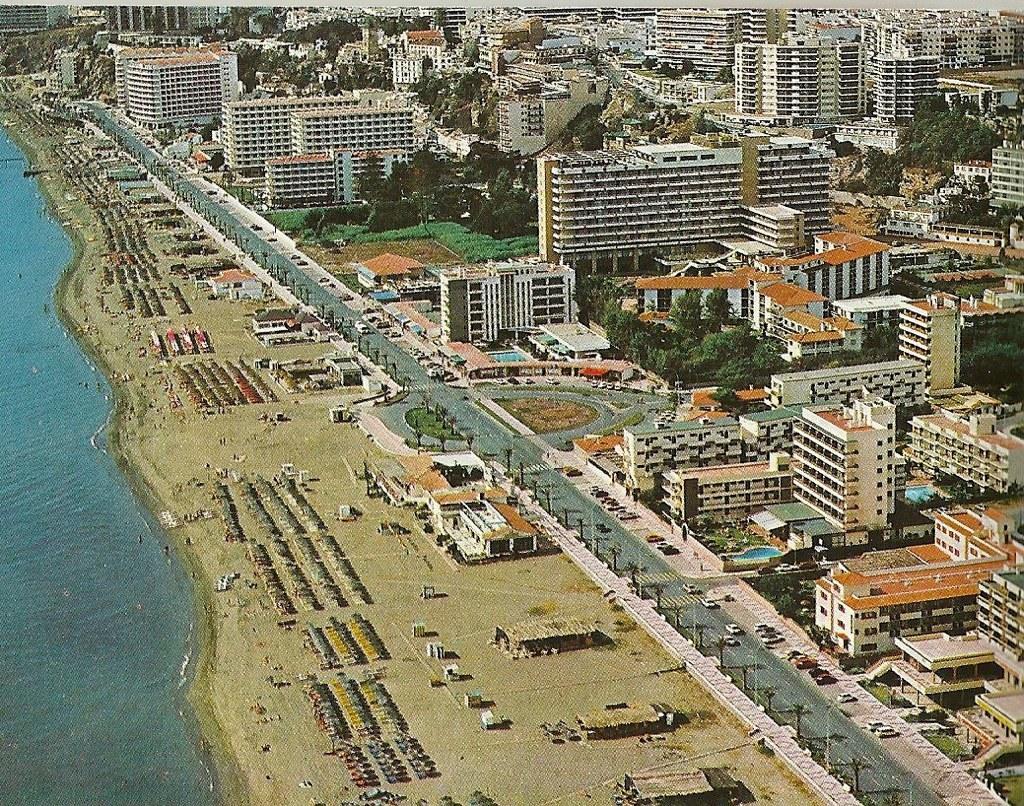Could you give a brief overview of what you see in this image? In this picture we can observe some buildings. There is a road on which some vehicles are moving. We can observe a beach. There are some trees. On the left side there is an ocean. 